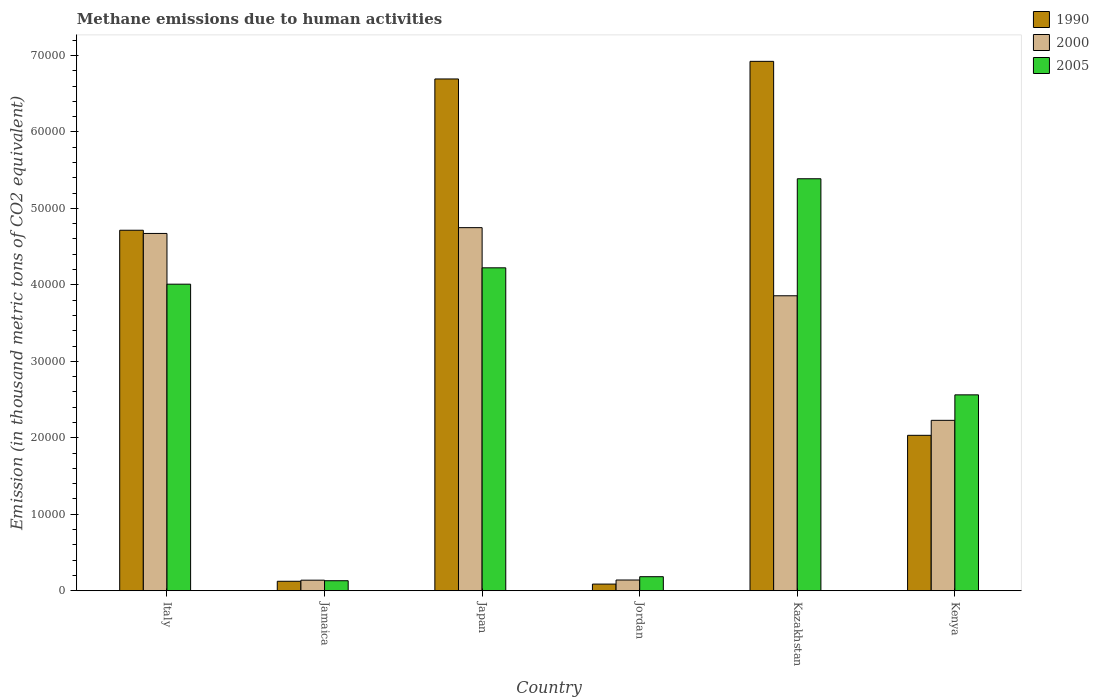How many different coloured bars are there?
Keep it short and to the point. 3. How many groups of bars are there?
Offer a very short reply. 6. Are the number of bars per tick equal to the number of legend labels?
Provide a succinct answer. Yes. Are the number of bars on each tick of the X-axis equal?
Provide a short and direct response. Yes. How many bars are there on the 2nd tick from the right?
Offer a very short reply. 3. What is the label of the 2nd group of bars from the left?
Your answer should be very brief. Jamaica. What is the amount of methane emitted in 2005 in Kazakhstan?
Your response must be concise. 5.39e+04. Across all countries, what is the maximum amount of methane emitted in 2005?
Provide a succinct answer. 5.39e+04. Across all countries, what is the minimum amount of methane emitted in 2000?
Provide a short and direct response. 1379.2. In which country was the amount of methane emitted in 1990 maximum?
Make the answer very short. Kazakhstan. In which country was the amount of methane emitted in 2005 minimum?
Your answer should be very brief. Jamaica. What is the total amount of methane emitted in 2000 in the graph?
Your answer should be compact. 1.58e+05. What is the difference between the amount of methane emitted in 1990 in Italy and that in Jordan?
Ensure brevity in your answer.  4.63e+04. What is the difference between the amount of methane emitted in 2005 in Japan and the amount of methane emitted in 1990 in Jamaica?
Give a very brief answer. 4.10e+04. What is the average amount of methane emitted in 2000 per country?
Provide a succinct answer. 2.63e+04. What is the difference between the amount of methane emitted of/in 1990 and amount of methane emitted of/in 2000 in Italy?
Keep it short and to the point. 418.9. In how many countries, is the amount of methane emitted in 1990 greater than 26000 thousand metric tons?
Offer a very short reply. 3. What is the ratio of the amount of methane emitted in 2000 in Jamaica to that in Jordan?
Provide a short and direct response. 0.98. Is the difference between the amount of methane emitted in 1990 in Italy and Japan greater than the difference between the amount of methane emitted in 2000 in Italy and Japan?
Provide a short and direct response. No. What is the difference between the highest and the second highest amount of methane emitted in 1990?
Offer a terse response. 2.21e+04. What is the difference between the highest and the lowest amount of methane emitted in 2000?
Your answer should be very brief. 4.61e+04. In how many countries, is the amount of methane emitted in 1990 greater than the average amount of methane emitted in 1990 taken over all countries?
Offer a terse response. 3. Is the sum of the amount of methane emitted in 1990 in Italy and Japan greater than the maximum amount of methane emitted in 2005 across all countries?
Ensure brevity in your answer.  Yes. What does the 2nd bar from the left in Japan represents?
Provide a short and direct response. 2000. Is it the case that in every country, the sum of the amount of methane emitted in 1990 and amount of methane emitted in 2005 is greater than the amount of methane emitted in 2000?
Your answer should be compact. Yes. Are all the bars in the graph horizontal?
Your answer should be very brief. No. How many countries are there in the graph?
Offer a very short reply. 6. Are the values on the major ticks of Y-axis written in scientific E-notation?
Provide a succinct answer. No. Does the graph contain any zero values?
Keep it short and to the point. No. Does the graph contain grids?
Give a very brief answer. No. How are the legend labels stacked?
Provide a short and direct response. Vertical. What is the title of the graph?
Your response must be concise. Methane emissions due to human activities. What is the label or title of the Y-axis?
Your answer should be compact. Emission (in thousand metric tons of CO2 equivalent). What is the Emission (in thousand metric tons of CO2 equivalent) in 1990 in Italy?
Your answer should be compact. 4.71e+04. What is the Emission (in thousand metric tons of CO2 equivalent) of 2000 in Italy?
Provide a succinct answer. 4.67e+04. What is the Emission (in thousand metric tons of CO2 equivalent) of 2005 in Italy?
Your answer should be compact. 4.01e+04. What is the Emission (in thousand metric tons of CO2 equivalent) of 1990 in Jamaica?
Give a very brief answer. 1235.1. What is the Emission (in thousand metric tons of CO2 equivalent) of 2000 in Jamaica?
Your answer should be compact. 1379.2. What is the Emission (in thousand metric tons of CO2 equivalent) in 2005 in Jamaica?
Make the answer very short. 1306.5. What is the Emission (in thousand metric tons of CO2 equivalent) of 1990 in Japan?
Your answer should be very brief. 6.69e+04. What is the Emission (in thousand metric tons of CO2 equivalent) in 2000 in Japan?
Ensure brevity in your answer.  4.75e+04. What is the Emission (in thousand metric tons of CO2 equivalent) in 2005 in Japan?
Provide a succinct answer. 4.22e+04. What is the Emission (in thousand metric tons of CO2 equivalent) of 1990 in Jordan?
Provide a short and direct response. 867.1. What is the Emission (in thousand metric tons of CO2 equivalent) in 2000 in Jordan?
Keep it short and to the point. 1401.8. What is the Emission (in thousand metric tons of CO2 equivalent) in 2005 in Jordan?
Make the answer very short. 1833.2. What is the Emission (in thousand metric tons of CO2 equivalent) in 1990 in Kazakhstan?
Offer a terse response. 6.92e+04. What is the Emission (in thousand metric tons of CO2 equivalent) in 2000 in Kazakhstan?
Provide a short and direct response. 3.86e+04. What is the Emission (in thousand metric tons of CO2 equivalent) of 2005 in Kazakhstan?
Make the answer very short. 5.39e+04. What is the Emission (in thousand metric tons of CO2 equivalent) in 1990 in Kenya?
Provide a succinct answer. 2.03e+04. What is the Emission (in thousand metric tons of CO2 equivalent) of 2000 in Kenya?
Your answer should be compact. 2.23e+04. What is the Emission (in thousand metric tons of CO2 equivalent) in 2005 in Kenya?
Your answer should be compact. 2.56e+04. Across all countries, what is the maximum Emission (in thousand metric tons of CO2 equivalent) of 1990?
Offer a terse response. 6.92e+04. Across all countries, what is the maximum Emission (in thousand metric tons of CO2 equivalent) of 2000?
Provide a succinct answer. 4.75e+04. Across all countries, what is the maximum Emission (in thousand metric tons of CO2 equivalent) in 2005?
Your answer should be compact. 5.39e+04. Across all countries, what is the minimum Emission (in thousand metric tons of CO2 equivalent) of 1990?
Offer a very short reply. 867.1. Across all countries, what is the minimum Emission (in thousand metric tons of CO2 equivalent) of 2000?
Your answer should be very brief. 1379.2. Across all countries, what is the minimum Emission (in thousand metric tons of CO2 equivalent) in 2005?
Make the answer very short. 1306.5. What is the total Emission (in thousand metric tons of CO2 equivalent) of 1990 in the graph?
Your answer should be very brief. 2.06e+05. What is the total Emission (in thousand metric tons of CO2 equivalent) in 2000 in the graph?
Offer a terse response. 1.58e+05. What is the total Emission (in thousand metric tons of CO2 equivalent) in 2005 in the graph?
Your response must be concise. 1.65e+05. What is the difference between the Emission (in thousand metric tons of CO2 equivalent) in 1990 in Italy and that in Jamaica?
Give a very brief answer. 4.59e+04. What is the difference between the Emission (in thousand metric tons of CO2 equivalent) of 2000 in Italy and that in Jamaica?
Provide a succinct answer. 4.53e+04. What is the difference between the Emission (in thousand metric tons of CO2 equivalent) in 2005 in Italy and that in Jamaica?
Provide a short and direct response. 3.88e+04. What is the difference between the Emission (in thousand metric tons of CO2 equivalent) of 1990 in Italy and that in Japan?
Your response must be concise. -1.98e+04. What is the difference between the Emission (in thousand metric tons of CO2 equivalent) in 2000 in Italy and that in Japan?
Your response must be concise. -758.6. What is the difference between the Emission (in thousand metric tons of CO2 equivalent) in 2005 in Italy and that in Japan?
Your answer should be very brief. -2140.2. What is the difference between the Emission (in thousand metric tons of CO2 equivalent) of 1990 in Italy and that in Jordan?
Offer a terse response. 4.63e+04. What is the difference between the Emission (in thousand metric tons of CO2 equivalent) of 2000 in Italy and that in Jordan?
Ensure brevity in your answer.  4.53e+04. What is the difference between the Emission (in thousand metric tons of CO2 equivalent) in 2005 in Italy and that in Jordan?
Give a very brief answer. 3.83e+04. What is the difference between the Emission (in thousand metric tons of CO2 equivalent) in 1990 in Italy and that in Kazakhstan?
Give a very brief answer. -2.21e+04. What is the difference between the Emission (in thousand metric tons of CO2 equivalent) in 2000 in Italy and that in Kazakhstan?
Offer a terse response. 8151.1. What is the difference between the Emission (in thousand metric tons of CO2 equivalent) of 2005 in Italy and that in Kazakhstan?
Provide a succinct answer. -1.38e+04. What is the difference between the Emission (in thousand metric tons of CO2 equivalent) of 1990 in Italy and that in Kenya?
Your response must be concise. 2.68e+04. What is the difference between the Emission (in thousand metric tons of CO2 equivalent) of 2000 in Italy and that in Kenya?
Your response must be concise. 2.44e+04. What is the difference between the Emission (in thousand metric tons of CO2 equivalent) in 2005 in Italy and that in Kenya?
Ensure brevity in your answer.  1.45e+04. What is the difference between the Emission (in thousand metric tons of CO2 equivalent) in 1990 in Jamaica and that in Japan?
Your answer should be compact. -6.57e+04. What is the difference between the Emission (in thousand metric tons of CO2 equivalent) in 2000 in Jamaica and that in Japan?
Your response must be concise. -4.61e+04. What is the difference between the Emission (in thousand metric tons of CO2 equivalent) of 2005 in Jamaica and that in Japan?
Offer a terse response. -4.09e+04. What is the difference between the Emission (in thousand metric tons of CO2 equivalent) in 1990 in Jamaica and that in Jordan?
Ensure brevity in your answer.  368. What is the difference between the Emission (in thousand metric tons of CO2 equivalent) of 2000 in Jamaica and that in Jordan?
Keep it short and to the point. -22.6. What is the difference between the Emission (in thousand metric tons of CO2 equivalent) of 2005 in Jamaica and that in Jordan?
Ensure brevity in your answer.  -526.7. What is the difference between the Emission (in thousand metric tons of CO2 equivalent) of 1990 in Jamaica and that in Kazakhstan?
Offer a very short reply. -6.80e+04. What is the difference between the Emission (in thousand metric tons of CO2 equivalent) of 2000 in Jamaica and that in Kazakhstan?
Your answer should be very brief. -3.72e+04. What is the difference between the Emission (in thousand metric tons of CO2 equivalent) of 2005 in Jamaica and that in Kazakhstan?
Your response must be concise. -5.26e+04. What is the difference between the Emission (in thousand metric tons of CO2 equivalent) of 1990 in Jamaica and that in Kenya?
Ensure brevity in your answer.  -1.91e+04. What is the difference between the Emission (in thousand metric tons of CO2 equivalent) in 2000 in Jamaica and that in Kenya?
Keep it short and to the point. -2.09e+04. What is the difference between the Emission (in thousand metric tons of CO2 equivalent) in 2005 in Jamaica and that in Kenya?
Your answer should be compact. -2.43e+04. What is the difference between the Emission (in thousand metric tons of CO2 equivalent) in 1990 in Japan and that in Jordan?
Provide a succinct answer. 6.61e+04. What is the difference between the Emission (in thousand metric tons of CO2 equivalent) in 2000 in Japan and that in Jordan?
Provide a short and direct response. 4.61e+04. What is the difference between the Emission (in thousand metric tons of CO2 equivalent) in 2005 in Japan and that in Jordan?
Keep it short and to the point. 4.04e+04. What is the difference between the Emission (in thousand metric tons of CO2 equivalent) in 1990 in Japan and that in Kazakhstan?
Make the answer very short. -2305. What is the difference between the Emission (in thousand metric tons of CO2 equivalent) of 2000 in Japan and that in Kazakhstan?
Ensure brevity in your answer.  8909.7. What is the difference between the Emission (in thousand metric tons of CO2 equivalent) in 2005 in Japan and that in Kazakhstan?
Keep it short and to the point. -1.16e+04. What is the difference between the Emission (in thousand metric tons of CO2 equivalent) in 1990 in Japan and that in Kenya?
Offer a very short reply. 4.66e+04. What is the difference between the Emission (in thousand metric tons of CO2 equivalent) in 2000 in Japan and that in Kenya?
Keep it short and to the point. 2.52e+04. What is the difference between the Emission (in thousand metric tons of CO2 equivalent) of 2005 in Japan and that in Kenya?
Give a very brief answer. 1.66e+04. What is the difference between the Emission (in thousand metric tons of CO2 equivalent) in 1990 in Jordan and that in Kazakhstan?
Keep it short and to the point. -6.84e+04. What is the difference between the Emission (in thousand metric tons of CO2 equivalent) of 2000 in Jordan and that in Kazakhstan?
Your answer should be very brief. -3.72e+04. What is the difference between the Emission (in thousand metric tons of CO2 equivalent) of 2005 in Jordan and that in Kazakhstan?
Your answer should be compact. -5.20e+04. What is the difference between the Emission (in thousand metric tons of CO2 equivalent) in 1990 in Jordan and that in Kenya?
Make the answer very short. -1.95e+04. What is the difference between the Emission (in thousand metric tons of CO2 equivalent) of 2000 in Jordan and that in Kenya?
Give a very brief answer. -2.09e+04. What is the difference between the Emission (in thousand metric tons of CO2 equivalent) in 2005 in Jordan and that in Kenya?
Your answer should be compact. -2.38e+04. What is the difference between the Emission (in thousand metric tons of CO2 equivalent) in 1990 in Kazakhstan and that in Kenya?
Provide a succinct answer. 4.89e+04. What is the difference between the Emission (in thousand metric tons of CO2 equivalent) of 2000 in Kazakhstan and that in Kenya?
Offer a terse response. 1.63e+04. What is the difference between the Emission (in thousand metric tons of CO2 equivalent) of 2005 in Kazakhstan and that in Kenya?
Provide a succinct answer. 2.83e+04. What is the difference between the Emission (in thousand metric tons of CO2 equivalent) in 1990 in Italy and the Emission (in thousand metric tons of CO2 equivalent) in 2000 in Jamaica?
Offer a very short reply. 4.58e+04. What is the difference between the Emission (in thousand metric tons of CO2 equivalent) of 1990 in Italy and the Emission (in thousand metric tons of CO2 equivalent) of 2005 in Jamaica?
Keep it short and to the point. 4.58e+04. What is the difference between the Emission (in thousand metric tons of CO2 equivalent) of 2000 in Italy and the Emission (in thousand metric tons of CO2 equivalent) of 2005 in Jamaica?
Provide a short and direct response. 4.54e+04. What is the difference between the Emission (in thousand metric tons of CO2 equivalent) in 1990 in Italy and the Emission (in thousand metric tons of CO2 equivalent) in 2000 in Japan?
Keep it short and to the point. -339.7. What is the difference between the Emission (in thousand metric tons of CO2 equivalent) of 1990 in Italy and the Emission (in thousand metric tons of CO2 equivalent) of 2005 in Japan?
Give a very brief answer. 4914.3. What is the difference between the Emission (in thousand metric tons of CO2 equivalent) of 2000 in Italy and the Emission (in thousand metric tons of CO2 equivalent) of 2005 in Japan?
Your answer should be compact. 4495.4. What is the difference between the Emission (in thousand metric tons of CO2 equivalent) of 1990 in Italy and the Emission (in thousand metric tons of CO2 equivalent) of 2000 in Jordan?
Ensure brevity in your answer.  4.57e+04. What is the difference between the Emission (in thousand metric tons of CO2 equivalent) in 1990 in Italy and the Emission (in thousand metric tons of CO2 equivalent) in 2005 in Jordan?
Give a very brief answer. 4.53e+04. What is the difference between the Emission (in thousand metric tons of CO2 equivalent) of 2000 in Italy and the Emission (in thousand metric tons of CO2 equivalent) of 2005 in Jordan?
Give a very brief answer. 4.49e+04. What is the difference between the Emission (in thousand metric tons of CO2 equivalent) of 1990 in Italy and the Emission (in thousand metric tons of CO2 equivalent) of 2000 in Kazakhstan?
Make the answer very short. 8570. What is the difference between the Emission (in thousand metric tons of CO2 equivalent) in 1990 in Italy and the Emission (in thousand metric tons of CO2 equivalent) in 2005 in Kazakhstan?
Offer a terse response. -6733. What is the difference between the Emission (in thousand metric tons of CO2 equivalent) in 2000 in Italy and the Emission (in thousand metric tons of CO2 equivalent) in 2005 in Kazakhstan?
Your answer should be compact. -7151.9. What is the difference between the Emission (in thousand metric tons of CO2 equivalent) in 1990 in Italy and the Emission (in thousand metric tons of CO2 equivalent) in 2000 in Kenya?
Your response must be concise. 2.49e+04. What is the difference between the Emission (in thousand metric tons of CO2 equivalent) in 1990 in Italy and the Emission (in thousand metric tons of CO2 equivalent) in 2005 in Kenya?
Provide a succinct answer. 2.15e+04. What is the difference between the Emission (in thousand metric tons of CO2 equivalent) of 2000 in Italy and the Emission (in thousand metric tons of CO2 equivalent) of 2005 in Kenya?
Provide a short and direct response. 2.11e+04. What is the difference between the Emission (in thousand metric tons of CO2 equivalent) of 1990 in Jamaica and the Emission (in thousand metric tons of CO2 equivalent) of 2000 in Japan?
Your answer should be compact. -4.62e+04. What is the difference between the Emission (in thousand metric tons of CO2 equivalent) in 1990 in Jamaica and the Emission (in thousand metric tons of CO2 equivalent) in 2005 in Japan?
Offer a terse response. -4.10e+04. What is the difference between the Emission (in thousand metric tons of CO2 equivalent) of 2000 in Jamaica and the Emission (in thousand metric tons of CO2 equivalent) of 2005 in Japan?
Keep it short and to the point. -4.09e+04. What is the difference between the Emission (in thousand metric tons of CO2 equivalent) of 1990 in Jamaica and the Emission (in thousand metric tons of CO2 equivalent) of 2000 in Jordan?
Offer a very short reply. -166.7. What is the difference between the Emission (in thousand metric tons of CO2 equivalent) of 1990 in Jamaica and the Emission (in thousand metric tons of CO2 equivalent) of 2005 in Jordan?
Provide a succinct answer. -598.1. What is the difference between the Emission (in thousand metric tons of CO2 equivalent) in 2000 in Jamaica and the Emission (in thousand metric tons of CO2 equivalent) in 2005 in Jordan?
Your answer should be compact. -454. What is the difference between the Emission (in thousand metric tons of CO2 equivalent) in 1990 in Jamaica and the Emission (in thousand metric tons of CO2 equivalent) in 2000 in Kazakhstan?
Give a very brief answer. -3.73e+04. What is the difference between the Emission (in thousand metric tons of CO2 equivalent) in 1990 in Jamaica and the Emission (in thousand metric tons of CO2 equivalent) in 2005 in Kazakhstan?
Make the answer very short. -5.26e+04. What is the difference between the Emission (in thousand metric tons of CO2 equivalent) of 2000 in Jamaica and the Emission (in thousand metric tons of CO2 equivalent) of 2005 in Kazakhstan?
Offer a very short reply. -5.25e+04. What is the difference between the Emission (in thousand metric tons of CO2 equivalent) of 1990 in Jamaica and the Emission (in thousand metric tons of CO2 equivalent) of 2000 in Kenya?
Offer a very short reply. -2.10e+04. What is the difference between the Emission (in thousand metric tons of CO2 equivalent) in 1990 in Jamaica and the Emission (in thousand metric tons of CO2 equivalent) in 2005 in Kenya?
Your response must be concise. -2.44e+04. What is the difference between the Emission (in thousand metric tons of CO2 equivalent) of 2000 in Jamaica and the Emission (in thousand metric tons of CO2 equivalent) of 2005 in Kenya?
Your answer should be very brief. -2.42e+04. What is the difference between the Emission (in thousand metric tons of CO2 equivalent) in 1990 in Japan and the Emission (in thousand metric tons of CO2 equivalent) in 2000 in Jordan?
Ensure brevity in your answer.  6.55e+04. What is the difference between the Emission (in thousand metric tons of CO2 equivalent) in 1990 in Japan and the Emission (in thousand metric tons of CO2 equivalent) in 2005 in Jordan?
Provide a short and direct response. 6.51e+04. What is the difference between the Emission (in thousand metric tons of CO2 equivalent) of 2000 in Japan and the Emission (in thousand metric tons of CO2 equivalent) of 2005 in Jordan?
Provide a succinct answer. 4.57e+04. What is the difference between the Emission (in thousand metric tons of CO2 equivalent) in 1990 in Japan and the Emission (in thousand metric tons of CO2 equivalent) in 2000 in Kazakhstan?
Make the answer very short. 2.84e+04. What is the difference between the Emission (in thousand metric tons of CO2 equivalent) of 1990 in Japan and the Emission (in thousand metric tons of CO2 equivalent) of 2005 in Kazakhstan?
Offer a very short reply. 1.31e+04. What is the difference between the Emission (in thousand metric tons of CO2 equivalent) of 2000 in Japan and the Emission (in thousand metric tons of CO2 equivalent) of 2005 in Kazakhstan?
Give a very brief answer. -6393.3. What is the difference between the Emission (in thousand metric tons of CO2 equivalent) in 1990 in Japan and the Emission (in thousand metric tons of CO2 equivalent) in 2000 in Kenya?
Your answer should be very brief. 4.46e+04. What is the difference between the Emission (in thousand metric tons of CO2 equivalent) in 1990 in Japan and the Emission (in thousand metric tons of CO2 equivalent) in 2005 in Kenya?
Keep it short and to the point. 4.13e+04. What is the difference between the Emission (in thousand metric tons of CO2 equivalent) of 2000 in Japan and the Emission (in thousand metric tons of CO2 equivalent) of 2005 in Kenya?
Keep it short and to the point. 2.19e+04. What is the difference between the Emission (in thousand metric tons of CO2 equivalent) in 1990 in Jordan and the Emission (in thousand metric tons of CO2 equivalent) in 2000 in Kazakhstan?
Provide a succinct answer. -3.77e+04. What is the difference between the Emission (in thousand metric tons of CO2 equivalent) of 1990 in Jordan and the Emission (in thousand metric tons of CO2 equivalent) of 2005 in Kazakhstan?
Provide a short and direct response. -5.30e+04. What is the difference between the Emission (in thousand metric tons of CO2 equivalent) in 2000 in Jordan and the Emission (in thousand metric tons of CO2 equivalent) in 2005 in Kazakhstan?
Keep it short and to the point. -5.25e+04. What is the difference between the Emission (in thousand metric tons of CO2 equivalent) of 1990 in Jordan and the Emission (in thousand metric tons of CO2 equivalent) of 2000 in Kenya?
Give a very brief answer. -2.14e+04. What is the difference between the Emission (in thousand metric tons of CO2 equivalent) of 1990 in Jordan and the Emission (in thousand metric tons of CO2 equivalent) of 2005 in Kenya?
Offer a terse response. -2.47e+04. What is the difference between the Emission (in thousand metric tons of CO2 equivalent) in 2000 in Jordan and the Emission (in thousand metric tons of CO2 equivalent) in 2005 in Kenya?
Give a very brief answer. -2.42e+04. What is the difference between the Emission (in thousand metric tons of CO2 equivalent) of 1990 in Kazakhstan and the Emission (in thousand metric tons of CO2 equivalent) of 2000 in Kenya?
Offer a very short reply. 4.69e+04. What is the difference between the Emission (in thousand metric tons of CO2 equivalent) in 1990 in Kazakhstan and the Emission (in thousand metric tons of CO2 equivalent) in 2005 in Kenya?
Keep it short and to the point. 4.36e+04. What is the difference between the Emission (in thousand metric tons of CO2 equivalent) of 2000 in Kazakhstan and the Emission (in thousand metric tons of CO2 equivalent) of 2005 in Kenya?
Your answer should be very brief. 1.30e+04. What is the average Emission (in thousand metric tons of CO2 equivalent) in 1990 per country?
Provide a succinct answer. 3.43e+04. What is the average Emission (in thousand metric tons of CO2 equivalent) in 2000 per country?
Your answer should be very brief. 2.63e+04. What is the average Emission (in thousand metric tons of CO2 equivalent) in 2005 per country?
Keep it short and to the point. 2.75e+04. What is the difference between the Emission (in thousand metric tons of CO2 equivalent) in 1990 and Emission (in thousand metric tons of CO2 equivalent) in 2000 in Italy?
Your answer should be very brief. 418.9. What is the difference between the Emission (in thousand metric tons of CO2 equivalent) of 1990 and Emission (in thousand metric tons of CO2 equivalent) of 2005 in Italy?
Offer a very short reply. 7054.5. What is the difference between the Emission (in thousand metric tons of CO2 equivalent) of 2000 and Emission (in thousand metric tons of CO2 equivalent) of 2005 in Italy?
Offer a terse response. 6635.6. What is the difference between the Emission (in thousand metric tons of CO2 equivalent) of 1990 and Emission (in thousand metric tons of CO2 equivalent) of 2000 in Jamaica?
Your response must be concise. -144.1. What is the difference between the Emission (in thousand metric tons of CO2 equivalent) in 1990 and Emission (in thousand metric tons of CO2 equivalent) in 2005 in Jamaica?
Offer a very short reply. -71.4. What is the difference between the Emission (in thousand metric tons of CO2 equivalent) in 2000 and Emission (in thousand metric tons of CO2 equivalent) in 2005 in Jamaica?
Offer a very short reply. 72.7. What is the difference between the Emission (in thousand metric tons of CO2 equivalent) of 1990 and Emission (in thousand metric tons of CO2 equivalent) of 2000 in Japan?
Your response must be concise. 1.94e+04. What is the difference between the Emission (in thousand metric tons of CO2 equivalent) of 1990 and Emission (in thousand metric tons of CO2 equivalent) of 2005 in Japan?
Make the answer very short. 2.47e+04. What is the difference between the Emission (in thousand metric tons of CO2 equivalent) of 2000 and Emission (in thousand metric tons of CO2 equivalent) of 2005 in Japan?
Your answer should be compact. 5254. What is the difference between the Emission (in thousand metric tons of CO2 equivalent) in 1990 and Emission (in thousand metric tons of CO2 equivalent) in 2000 in Jordan?
Offer a very short reply. -534.7. What is the difference between the Emission (in thousand metric tons of CO2 equivalent) in 1990 and Emission (in thousand metric tons of CO2 equivalent) in 2005 in Jordan?
Make the answer very short. -966.1. What is the difference between the Emission (in thousand metric tons of CO2 equivalent) in 2000 and Emission (in thousand metric tons of CO2 equivalent) in 2005 in Jordan?
Ensure brevity in your answer.  -431.4. What is the difference between the Emission (in thousand metric tons of CO2 equivalent) in 1990 and Emission (in thousand metric tons of CO2 equivalent) in 2000 in Kazakhstan?
Make the answer very short. 3.07e+04. What is the difference between the Emission (in thousand metric tons of CO2 equivalent) in 1990 and Emission (in thousand metric tons of CO2 equivalent) in 2005 in Kazakhstan?
Offer a very short reply. 1.54e+04. What is the difference between the Emission (in thousand metric tons of CO2 equivalent) in 2000 and Emission (in thousand metric tons of CO2 equivalent) in 2005 in Kazakhstan?
Your response must be concise. -1.53e+04. What is the difference between the Emission (in thousand metric tons of CO2 equivalent) of 1990 and Emission (in thousand metric tons of CO2 equivalent) of 2000 in Kenya?
Offer a terse response. -1959.7. What is the difference between the Emission (in thousand metric tons of CO2 equivalent) in 1990 and Emission (in thousand metric tons of CO2 equivalent) in 2005 in Kenya?
Offer a very short reply. -5291.2. What is the difference between the Emission (in thousand metric tons of CO2 equivalent) in 2000 and Emission (in thousand metric tons of CO2 equivalent) in 2005 in Kenya?
Give a very brief answer. -3331.5. What is the ratio of the Emission (in thousand metric tons of CO2 equivalent) in 1990 in Italy to that in Jamaica?
Offer a terse response. 38.17. What is the ratio of the Emission (in thousand metric tons of CO2 equivalent) of 2000 in Italy to that in Jamaica?
Your response must be concise. 33.88. What is the ratio of the Emission (in thousand metric tons of CO2 equivalent) in 2005 in Italy to that in Jamaica?
Ensure brevity in your answer.  30.68. What is the ratio of the Emission (in thousand metric tons of CO2 equivalent) of 1990 in Italy to that in Japan?
Make the answer very short. 0.7. What is the ratio of the Emission (in thousand metric tons of CO2 equivalent) in 2005 in Italy to that in Japan?
Give a very brief answer. 0.95. What is the ratio of the Emission (in thousand metric tons of CO2 equivalent) of 1990 in Italy to that in Jordan?
Provide a short and direct response. 54.37. What is the ratio of the Emission (in thousand metric tons of CO2 equivalent) of 2000 in Italy to that in Jordan?
Ensure brevity in your answer.  33.33. What is the ratio of the Emission (in thousand metric tons of CO2 equivalent) of 2005 in Italy to that in Jordan?
Offer a terse response. 21.87. What is the ratio of the Emission (in thousand metric tons of CO2 equivalent) in 1990 in Italy to that in Kazakhstan?
Make the answer very short. 0.68. What is the ratio of the Emission (in thousand metric tons of CO2 equivalent) of 2000 in Italy to that in Kazakhstan?
Your response must be concise. 1.21. What is the ratio of the Emission (in thousand metric tons of CO2 equivalent) in 2005 in Italy to that in Kazakhstan?
Make the answer very short. 0.74. What is the ratio of the Emission (in thousand metric tons of CO2 equivalent) in 1990 in Italy to that in Kenya?
Provide a short and direct response. 2.32. What is the ratio of the Emission (in thousand metric tons of CO2 equivalent) in 2000 in Italy to that in Kenya?
Your answer should be very brief. 2.1. What is the ratio of the Emission (in thousand metric tons of CO2 equivalent) of 2005 in Italy to that in Kenya?
Ensure brevity in your answer.  1.56. What is the ratio of the Emission (in thousand metric tons of CO2 equivalent) of 1990 in Jamaica to that in Japan?
Provide a short and direct response. 0.02. What is the ratio of the Emission (in thousand metric tons of CO2 equivalent) in 2000 in Jamaica to that in Japan?
Keep it short and to the point. 0.03. What is the ratio of the Emission (in thousand metric tons of CO2 equivalent) of 2005 in Jamaica to that in Japan?
Your answer should be compact. 0.03. What is the ratio of the Emission (in thousand metric tons of CO2 equivalent) of 1990 in Jamaica to that in Jordan?
Make the answer very short. 1.42. What is the ratio of the Emission (in thousand metric tons of CO2 equivalent) in 2000 in Jamaica to that in Jordan?
Provide a short and direct response. 0.98. What is the ratio of the Emission (in thousand metric tons of CO2 equivalent) in 2005 in Jamaica to that in Jordan?
Offer a terse response. 0.71. What is the ratio of the Emission (in thousand metric tons of CO2 equivalent) of 1990 in Jamaica to that in Kazakhstan?
Make the answer very short. 0.02. What is the ratio of the Emission (in thousand metric tons of CO2 equivalent) in 2000 in Jamaica to that in Kazakhstan?
Give a very brief answer. 0.04. What is the ratio of the Emission (in thousand metric tons of CO2 equivalent) of 2005 in Jamaica to that in Kazakhstan?
Provide a succinct answer. 0.02. What is the ratio of the Emission (in thousand metric tons of CO2 equivalent) of 1990 in Jamaica to that in Kenya?
Keep it short and to the point. 0.06. What is the ratio of the Emission (in thousand metric tons of CO2 equivalent) of 2000 in Jamaica to that in Kenya?
Keep it short and to the point. 0.06. What is the ratio of the Emission (in thousand metric tons of CO2 equivalent) in 2005 in Jamaica to that in Kenya?
Your answer should be compact. 0.05. What is the ratio of the Emission (in thousand metric tons of CO2 equivalent) of 1990 in Japan to that in Jordan?
Make the answer very short. 77.19. What is the ratio of the Emission (in thousand metric tons of CO2 equivalent) of 2000 in Japan to that in Jordan?
Keep it short and to the point. 33.87. What is the ratio of the Emission (in thousand metric tons of CO2 equivalent) in 2005 in Japan to that in Jordan?
Provide a short and direct response. 23.04. What is the ratio of the Emission (in thousand metric tons of CO2 equivalent) in 1990 in Japan to that in Kazakhstan?
Your response must be concise. 0.97. What is the ratio of the Emission (in thousand metric tons of CO2 equivalent) of 2000 in Japan to that in Kazakhstan?
Provide a short and direct response. 1.23. What is the ratio of the Emission (in thousand metric tons of CO2 equivalent) in 2005 in Japan to that in Kazakhstan?
Ensure brevity in your answer.  0.78. What is the ratio of the Emission (in thousand metric tons of CO2 equivalent) in 1990 in Japan to that in Kenya?
Provide a short and direct response. 3.29. What is the ratio of the Emission (in thousand metric tons of CO2 equivalent) of 2000 in Japan to that in Kenya?
Provide a succinct answer. 2.13. What is the ratio of the Emission (in thousand metric tons of CO2 equivalent) in 2005 in Japan to that in Kenya?
Provide a succinct answer. 1.65. What is the ratio of the Emission (in thousand metric tons of CO2 equivalent) in 1990 in Jordan to that in Kazakhstan?
Offer a very short reply. 0.01. What is the ratio of the Emission (in thousand metric tons of CO2 equivalent) of 2000 in Jordan to that in Kazakhstan?
Your answer should be compact. 0.04. What is the ratio of the Emission (in thousand metric tons of CO2 equivalent) in 2005 in Jordan to that in Kazakhstan?
Your response must be concise. 0.03. What is the ratio of the Emission (in thousand metric tons of CO2 equivalent) of 1990 in Jordan to that in Kenya?
Provide a short and direct response. 0.04. What is the ratio of the Emission (in thousand metric tons of CO2 equivalent) of 2000 in Jordan to that in Kenya?
Give a very brief answer. 0.06. What is the ratio of the Emission (in thousand metric tons of CO2 equivalent) of 2005 in Jordan to that in Kenya?
Your answer should be compact. 0.07. What is the ratio of the Emission (in thousand metric tons of CO2 equivalent) of 1990 in Kazakhstan to that in Kenya?
Provide a succinct answer. 3.41. What is the ratio of the Emission (in thousand metric tons of CO2 equivalent) in 2000 in Kazakhstan to that in Kenya?
Make the answer very short. 1.73. What is the ratio of the Emission (in thousand metric tons of CO2 equivalent) of 2005 in Kazakhstan to that in Kenya?
Give a very brief answer. 2.1. What is the difference between the highest and the second highest Emission (in thousand metric tons of CO2 equivalent) in 1990?
Offer a terse response. 2305. What is the difference between the highest and the second highest Emission (in thousand metric tons of CO2 equivalent) in 2000?
Give a very brief answer. 758.6. What is the difference between the highest and the second highest Emission (in thousand metric tons of CO2 equivalent) in 2005?
Keep it short and to the point. 1.16e+04. What is the difference between the highest and the lowest Emission (in thousand metric tons of CO2 equivalent) of 1990?
Provide a succinct answer. 6.84e+04. What is the difference between the highest and the lowest Emission (in thousand metric tons of CO2 equivalent) in 2000?
Make the answer very short. 4.61e+04. What is the difference between the highest and the lowest Emission (in thousand metric tons of CO2 equivalent) in 2005?
Your answer should be compact. 5.26e+04. 